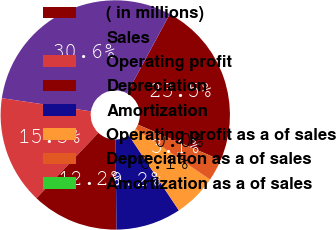<chart> <loc_0><loc_0><loc_500><loc_500><pie_chart><fcel>( in millions)<fcel>Sales<fcel>Operating profit<fcel>Depreciation<fcel>Amortization<fcel>Operating profit as a of sales<fcel>Depreciation as a of sales<fcel>Amortization as a of sales<nl><fcel>23.55%<fcel>30.56%<fcel>15.28%<fcel>12.23%<fcel>9.18%<fcel>6.12%<fcel>3.07%<fcel>0.01%<nl></chart> 